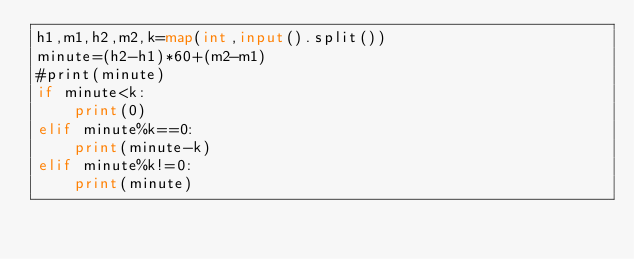Convert code to text. <code><loc_0><loc_0><loc_500><loc_500><_Python_>h1,m1,h2,m2,k=map(int,input().split())
minute=(h2-h1)*60+(m2-m1)
#print(minute)
if minute<k:
    print(0)
elif minute%k==0:
    print(minute-k)
elif minute%k!=0:
    print(minute)
</code> 